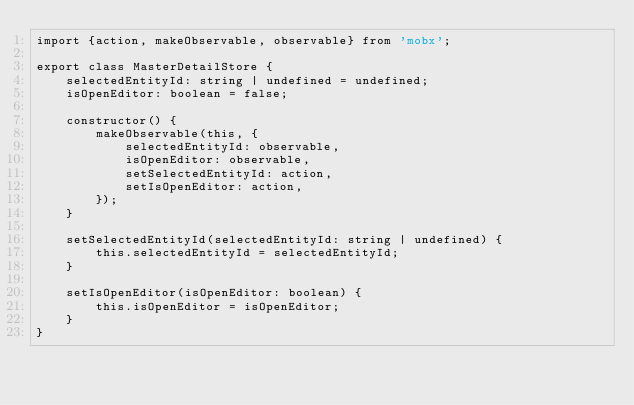<code> <loc_0><loc_0><loc_500><loc_500><_TypeScript_>import {action, makeObservable, observable} from 'mobx';

export class MasterDetailStore {
    selectedEntityId: string | undefined = undefined;
    isOpenEditor: boolean = false;

    constructor() {
        makeObservable(this, {
            selectedEntityId: observable,
            isOpenEditor: observable,
            setSelectedEntityId: action,
            setIsOpenEditor: action,
        });
    }

    setSelectedEntityId(selectedEntityId: string | undefined) {
        this.selectedEntityId = selectedEntityId;
    }

    setIsOpenEditor(isOpenEditor: boolean) {
        this.isOpenEditor = isOpenEditor;
    }
}
</code> 